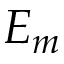Convert formula to latex. <formula><loc_0><loc_0><loc_500><loc_500>E _ { m }</formula> 